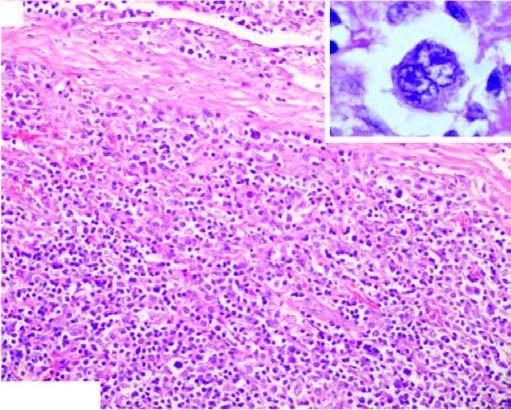s the margin of the colony admixture of mature lymphocytes, plasma cells, neutrophils and eosinophils and classic rs cells in the centre of the field inbox in right figure?
Answer the question using a single word or phrase. No 